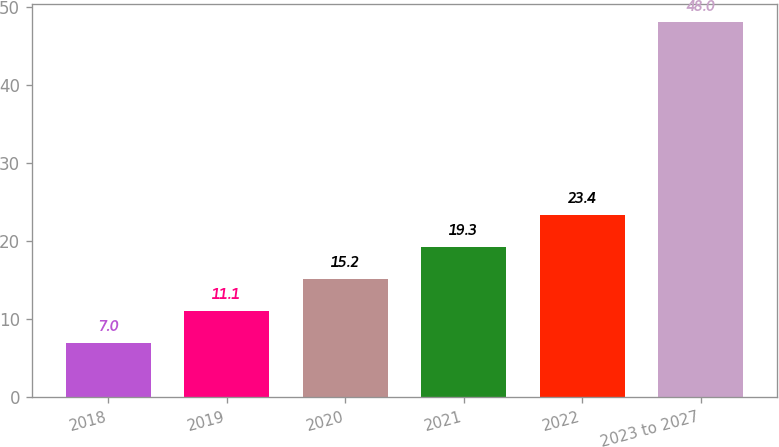Convert chart. <chart><loc_0><loc_0><loc_500><loc_500><bar_chart><fcel>2018<fcel>2019<fcel>2020<fcel>2021<fcel>2022<fcel>2023 to 2027<nl><fcel>7<fcel>11.1<fcel>15.2<fcel>19.3<fcel>23.4<fcel>48<nl></chart> 